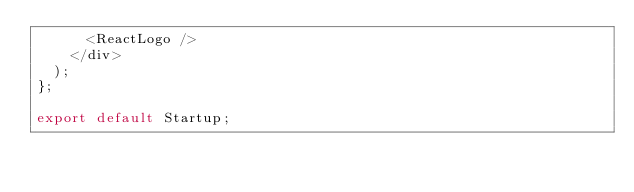<code> <loc_0><loc_0><loc_500><loc_500><_JavaScript_>      <ReactLogo />
    </div>
  );
};

export default Startup;
</code> 